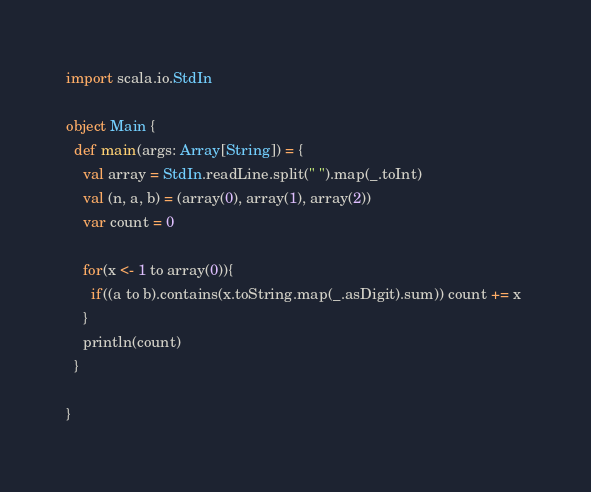Convert code to text. <code><loc_0><loc_0><loc_500><loc_500><_Scala_>import scala.io.StdIn

object Main {
  def main(args: Array[String]) = {
    val array = StdIn.readLine.split(" ").map(_.toInt)
    val (n, a, b) = (array(0), array(1), array(2))
    var count = 0
   
    for(x <- 1 to array(0)){
      if((a to b).contains(x.toString.map(_.asDigit).sum)) count += x 
    }
    println(count)
  }
  
}</code> 